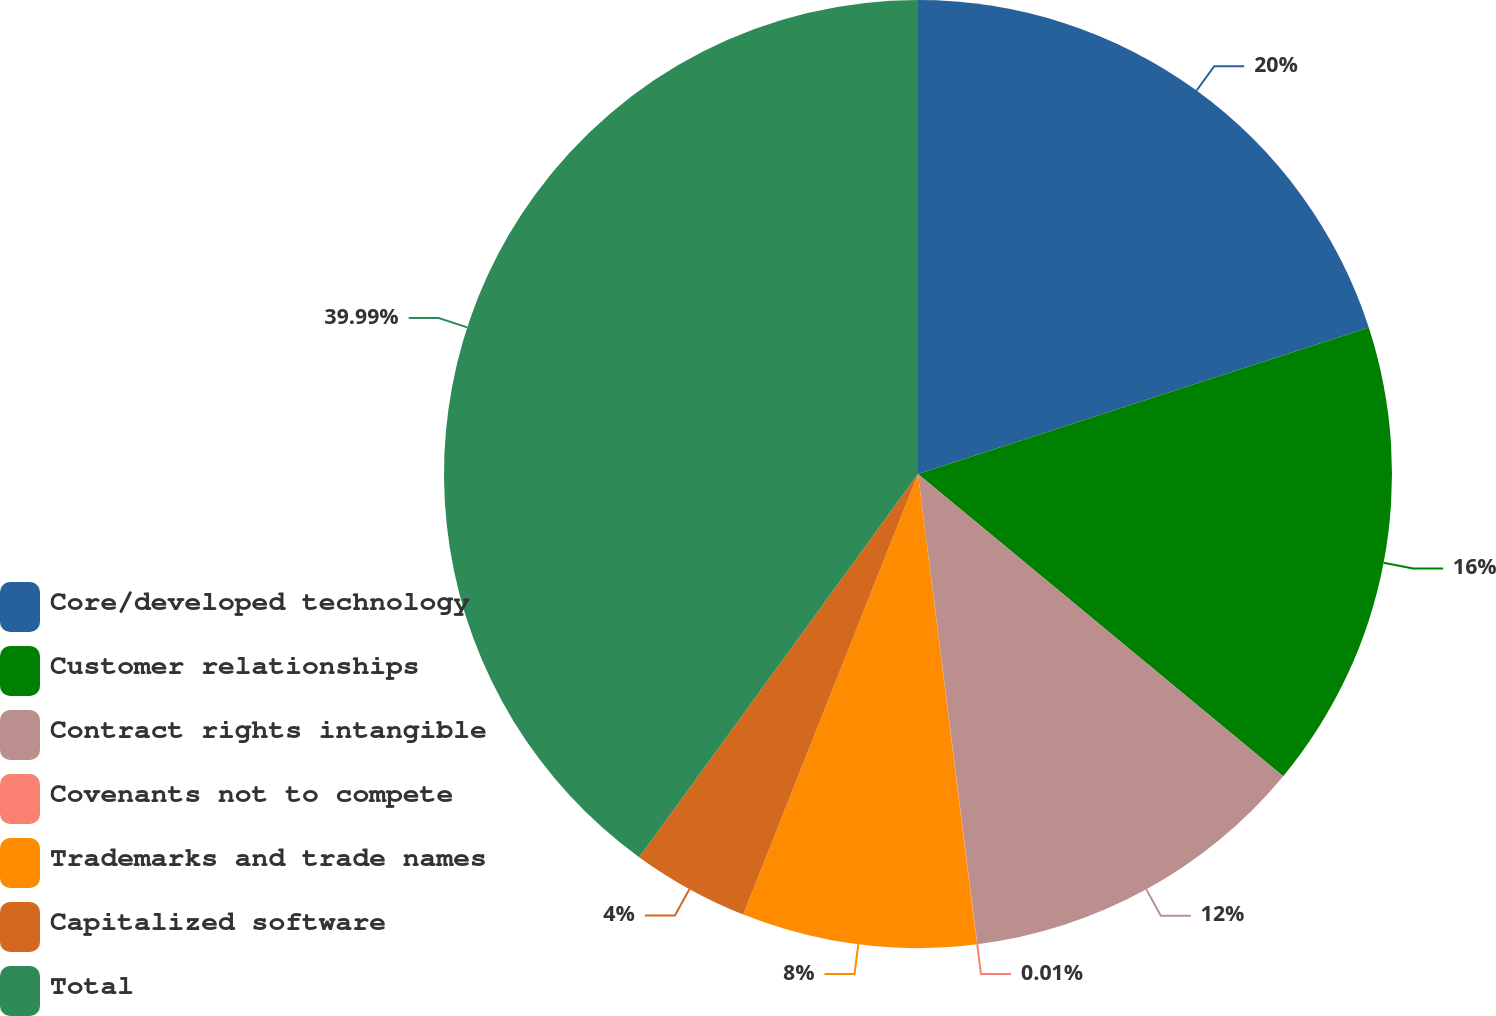Convert chart. <chart><loc_0><loc_0><loc_500><loc_500><pie_chart><fcel>Core/developed technology<fcel>Customer relationships<fcel>Contract rights intangible<fcel>Covenants not to compete<fcel>Trademarks and trade names<fcel>Capitalized software<fcel>Total<nl><fcel>20.0%<fcel>16.0%<fcel>12.0%<fcel>0.01%<fcel>8.0%<fcel>4.0%<fcel>39.99%<nl></chart> 